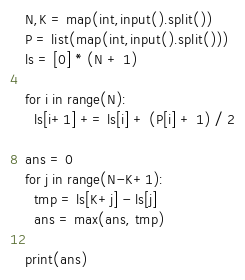Convert code to text. <code><loc_0><loc_0><loc_500><loc_500><_Python_>N,K = map(int,input().split())
P = list(map(int,input().split()))
ls = [0] * (N + 1)

for i in range(N):
  ls[i+1] += ls[i] + (P[i] + 1) / 2
  
ans = 0
for j in range(N-K+1):
  tmp = ls[K+j] - ls[j]
  ans = max(ans, tmp)
  
print(ans)</code> 